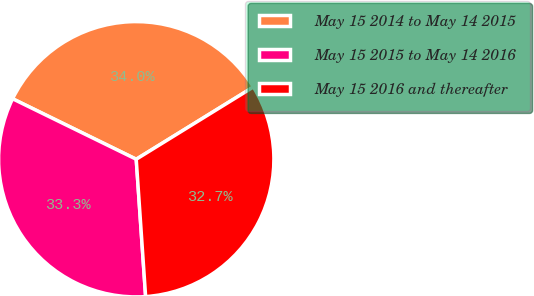Convert chart. <chart><loc_0><loc_0><loc_500><loc_500><pie_chart><fcel>May 15 2014 to May 14 2015<fcel>May 15 2015 to May 14 2016<fcel>May 15 2016 and thereafter<nl><fcel>33.96%<fcel>33.33%<fcel>32.71%<nl></chart> 